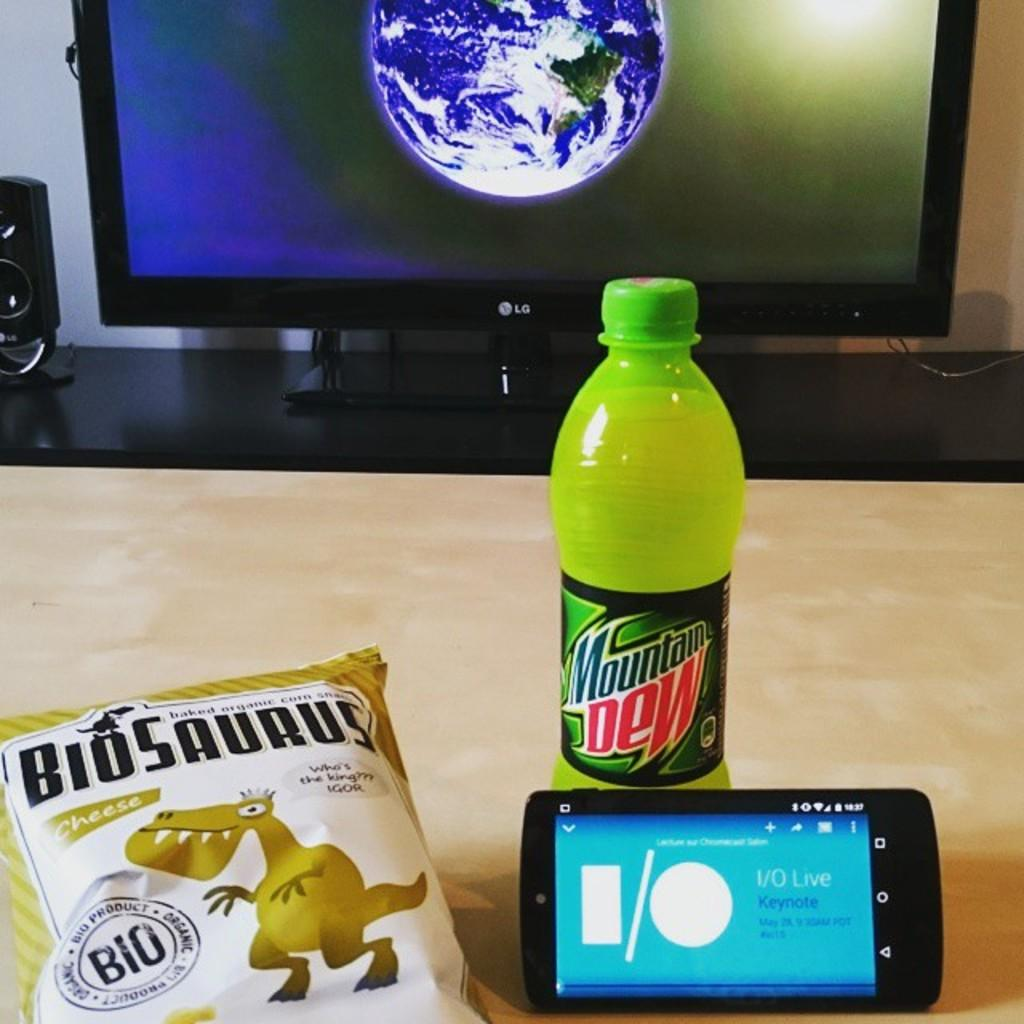<image>
Write a terse but informative summary of the picture. An unopened bottle of Mountain Dew next to an unopened bag of Biosaurus Cheese corn snacks next to a smartphone. 